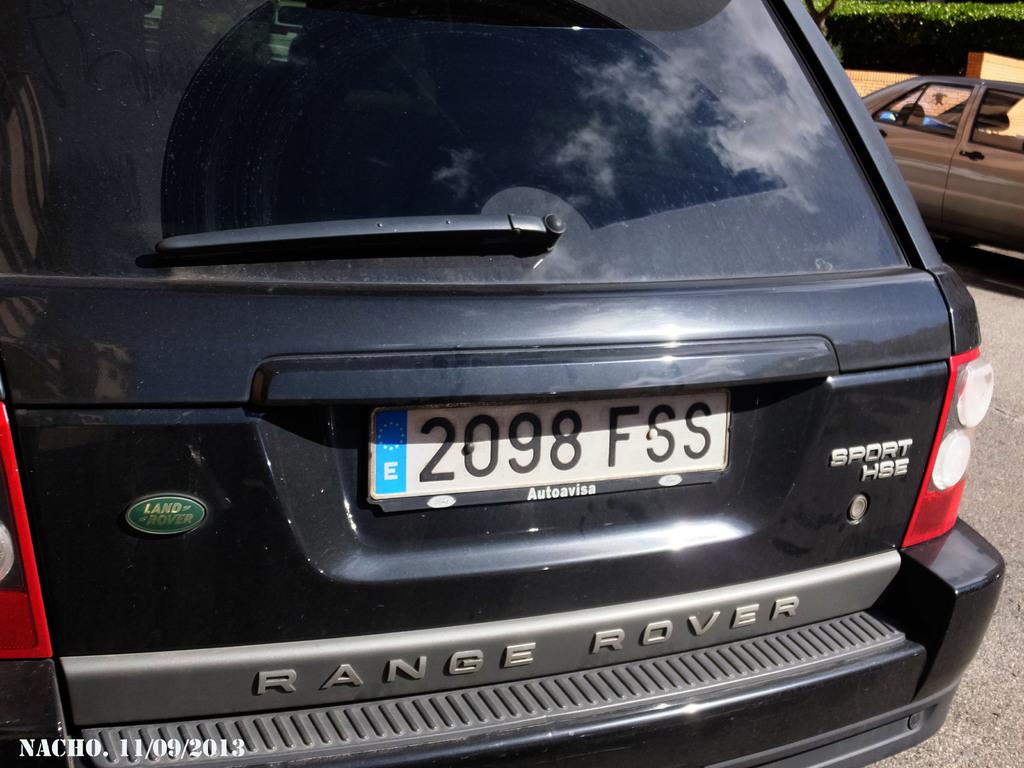What four numbers are on the license plate?
Keep it short and to the point. 2098. 